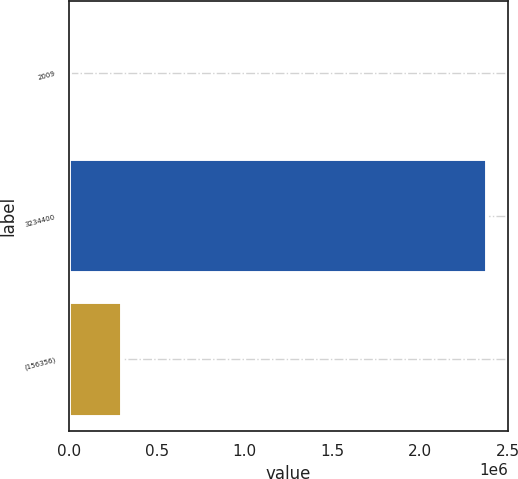Convert chart to OTSL. <chart><loc_0><loc_0><loc_500><loc_500><bar_chart><fcel>2009<fcel>3234400<fcel>(156356)<nl><fcel>2007<fcel>2.3813e+06<fcel>301608<nl></chart> 